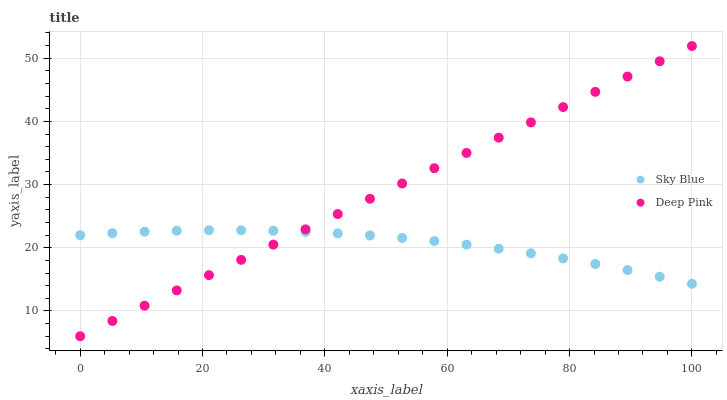Does Sky Blue have the minimum area under the curve?
Answer yes or no. Yes. Does Deep Pink have the maximum area under the curve?
Answer yes or no. Yes. Does Deep Pink have the minimum area under the curve?
Answer yes or no. No. Is Deep Pink the smoothest?
Answer yes or no. Yes. Is Sky Blue the roughest?
Answer yes or no. Yes. Is Deep Pink the roughest?
Answer yes or no. No. Does Deep Pink have the lowest value?
Answer yes or no. Yes. Does Deep Pink have the highest value?
Answer yes or no. Yes. Does Sky Blue intersect Deep Pink?
Answer yes or no. Yes. Is Sky Blue less than Deep Pink?
Answer yes or no. No. Is Sky Blue greater than Deep Pink?
Answer yes or no. No. 